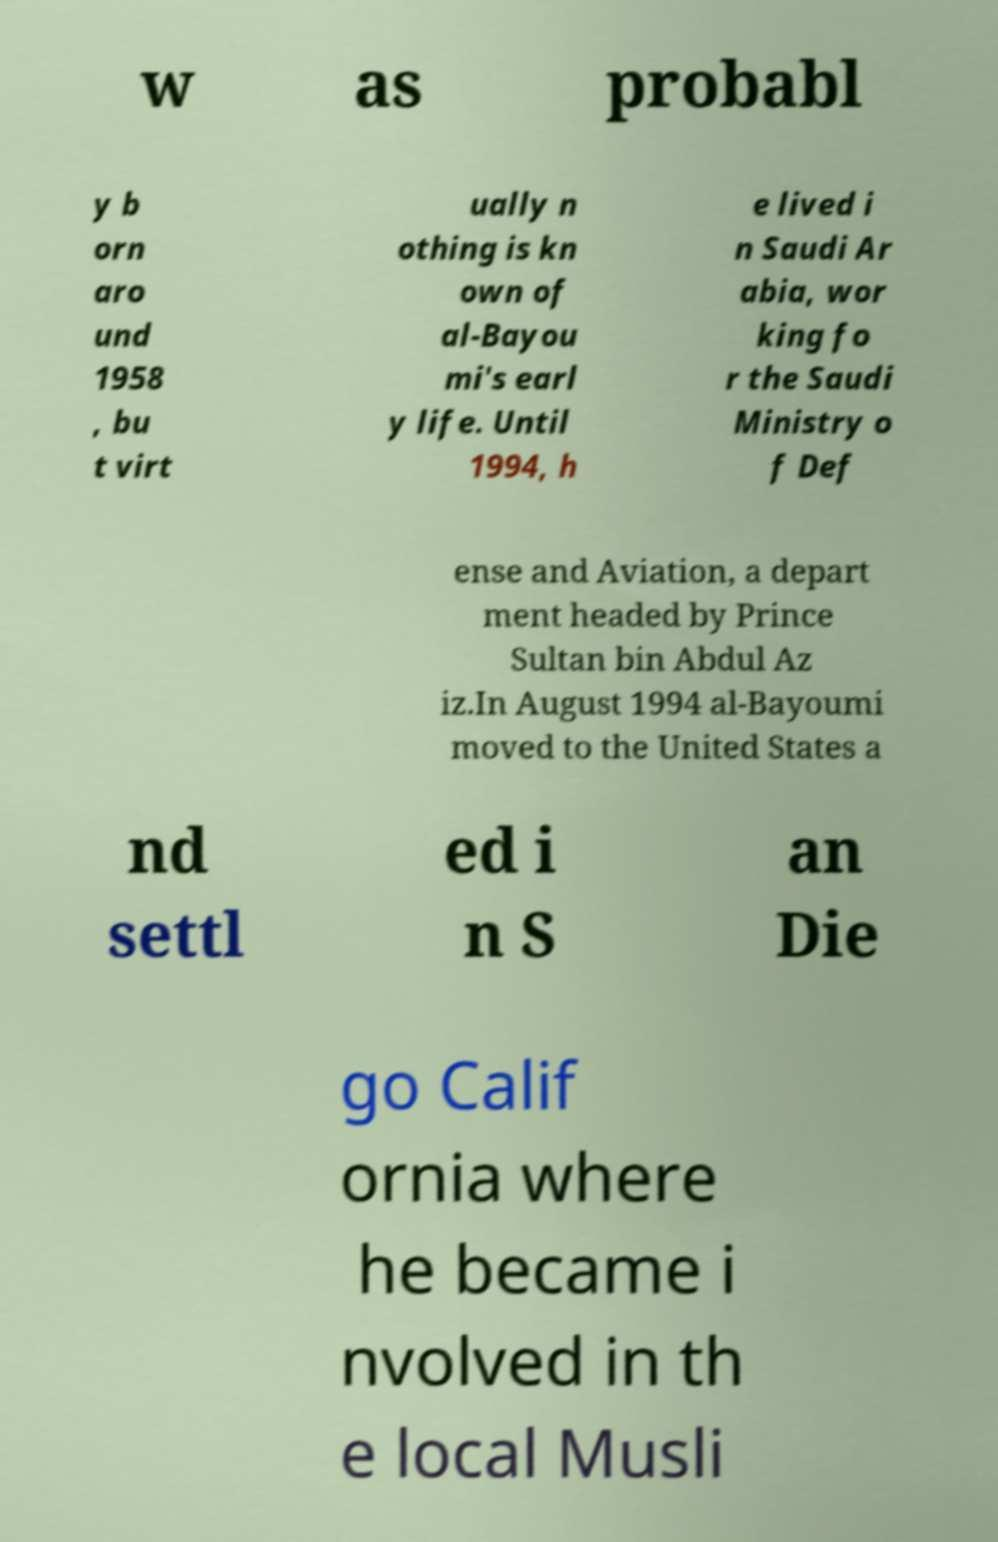For documentation purposes, I need the text within this image transcribed. Could you provide that? w as probabl y b orn aro und 1958 , bu t virt ually n othing is kn own of al-Bayou mi's earl y life. Until 1994, h e lived i n Saudi Ar abia, wor king fo r the Saudi Ministry o f Def ense and Aviation, a depart ment headed by Prince Sultan bin Abdul Az iz.In August 1994 al-Bayoumi moved to the United States a nd settl ed i n S an Die go Calif ornia where he became i nvolved in th e local Musli 